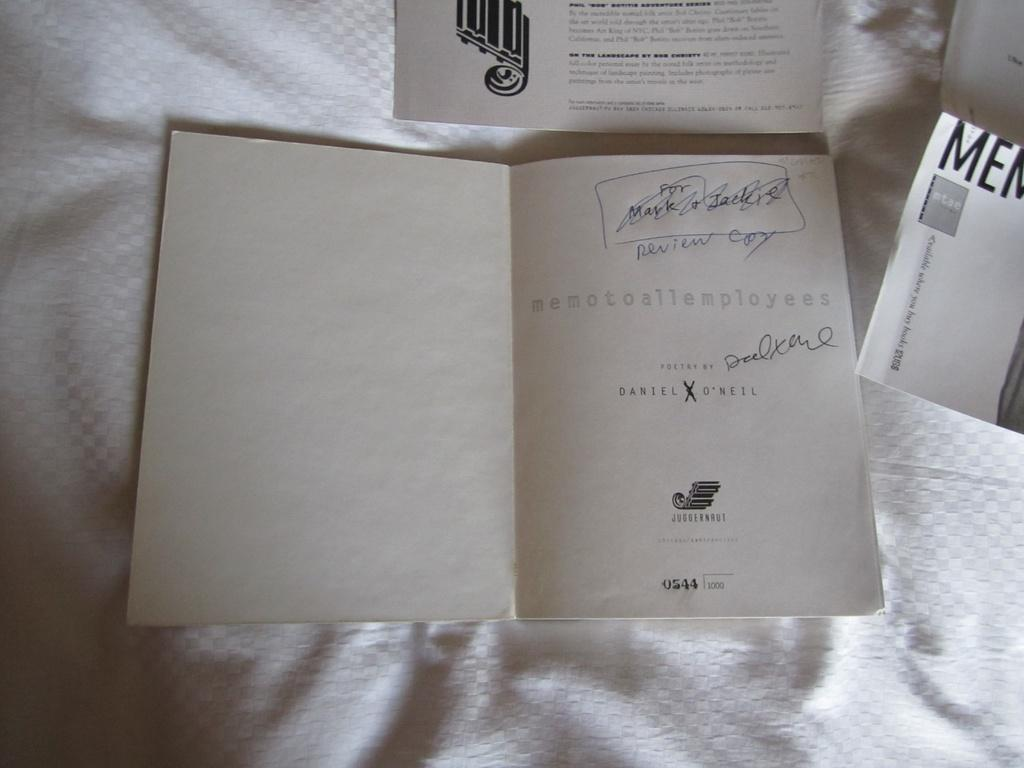<image>
Offer a succinct explanation of the picture presented. The back of a card is visible with handwriting at the top that says review.copy. 